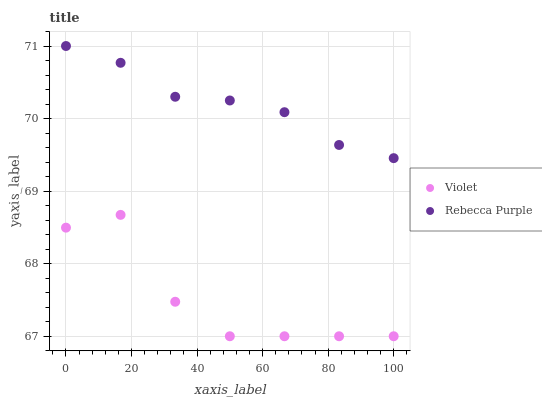Does Violet have the minimum area under the curve?
Answer yes or no. Yes. Does Rebecca Purple have the maximum area under the curve?
Answer yes or no. Yes. Does Violet have the maximum area under the curve?
Answer yes or no. No. Is Rebecca Purple the smoothest?
Answer yes or no. Yes. Is Violet the roughest?
Answer yes or no. Yes. Is Violet the smoothest?
Answer yes or no. No. Does Violet have the lowest value?
Answer yes or no. Yes. Does Rebecca Purple have the highest value?
Answer yes or no. Yes. Does Violet have the highest value?
Answer yes or no. No. Is Violet less than Rebecca Purple?
Answer yes or no. Yes. Is Rebecca Purple greater than Violet?
Answer yes or no. Yes. Does Violet intersect Rebecca Purple?
Answer yes or no. No. 